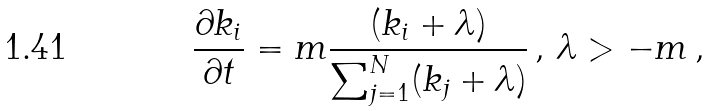<formula> <loc_0><loc_0><loc_500><loc_500>\frac { \partial k _ { i } } { \partial t } = m \frac { ( k _ { i } + \lambda ) } { \sum _ { j = 1 } ^ { N } ( k _ { j } + \lambda ) } \, , \, \lambda > - m \, ,</formula> 